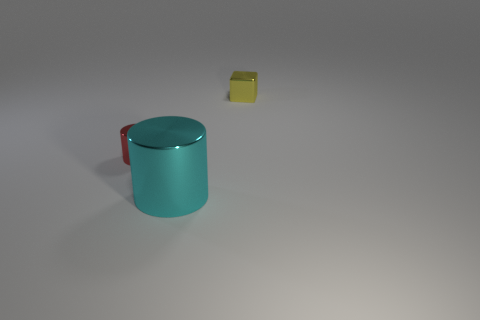Add 2 cyan shiny objects. How many objects exist? 5 Subtract all cubes. How many objects are left? 2 Add 3 big spheres. How many big spheres exist? 3 Subtract 0 gray spheres. How many objects are left? 3 Subtract all purple cubes. Subtract all yellow metal objects. How many objects are left? 2 Add 3 cyan metal objects. How many cyan metal objects are left? 4 